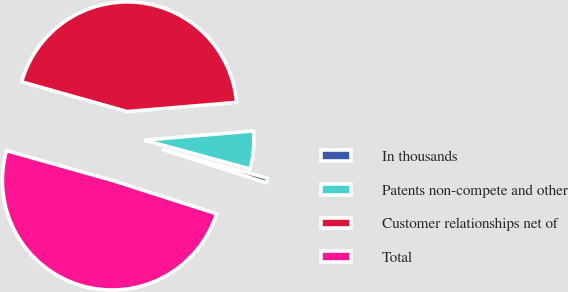Convert chart. <chart><loc_0><loc_0><loc_500><loc_500><pie_chart><fcel>In thousands<fcel>Patents non-compete and other<fcel>Customer relationships net of<fcel>Total<nl><fcel>0.7%<fcel>5.57%<fcel>44.3%<fcel>49.44%<nl></chart> 